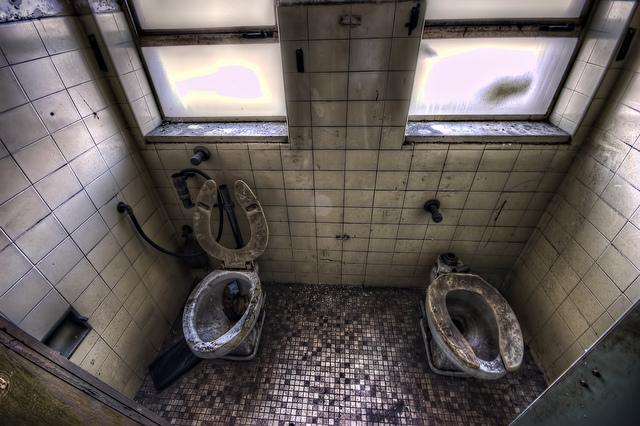Is this an old room?
Concise answer only. Yes. How many toilets are seen?
Be succinct. 2. Is the toilet clean?
Quick response, please. No. 